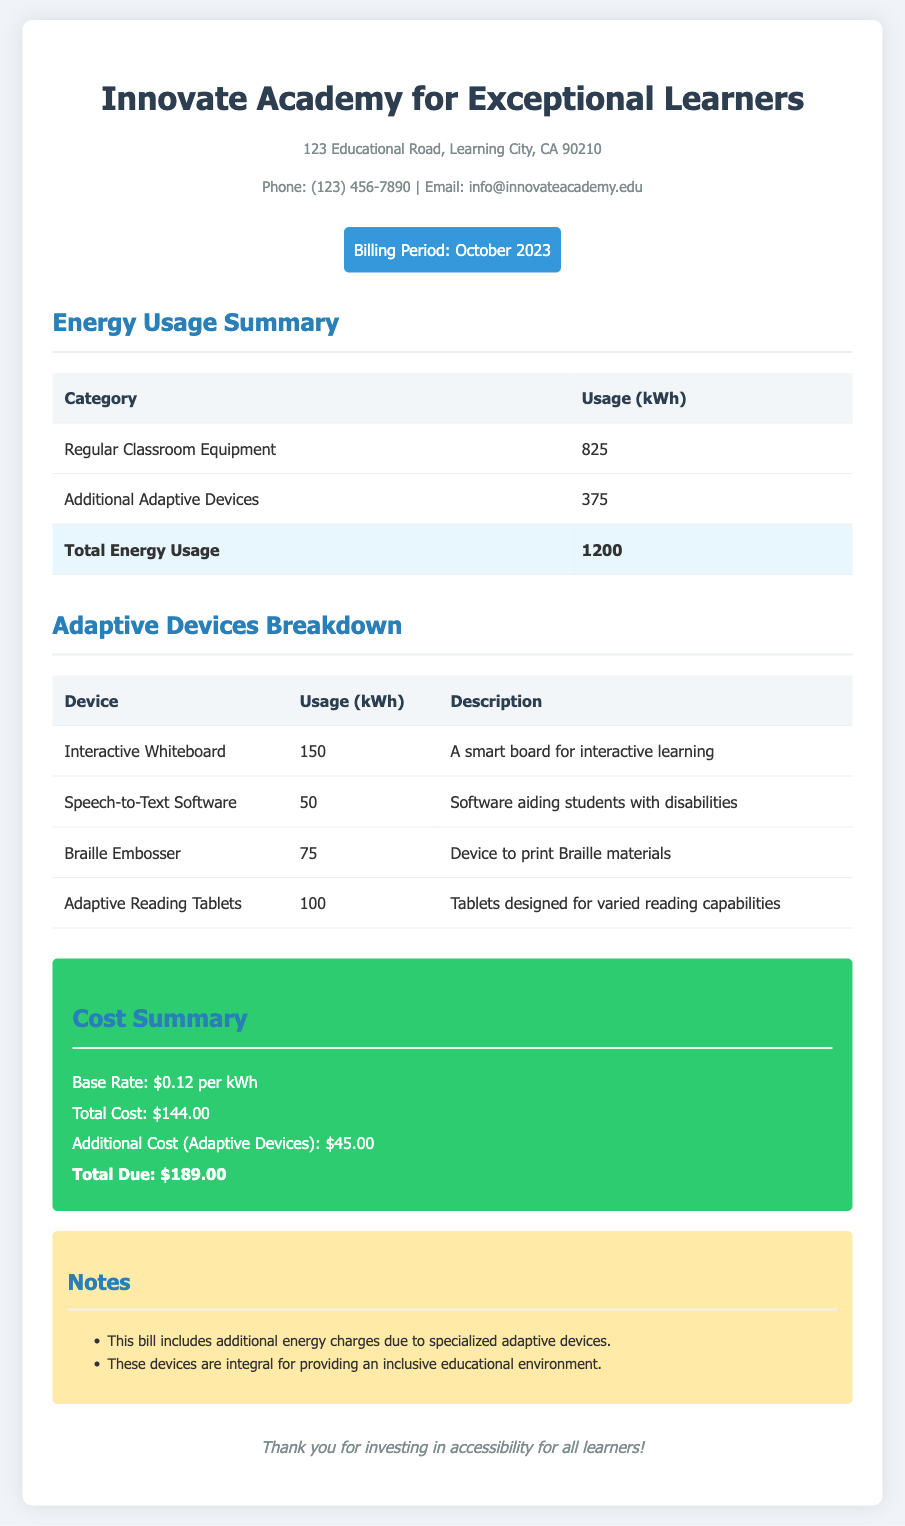What is the total energy usage? The total energy usage is the sum of regular classroom equipment and additional adaptive devices usage, which is 825 kWh + 375 kWh = 1200 kWh.
Answer: 1200 kWh What is the additional cost for adaptive devices? The additional cost for adaptive devices is specified in the cost summary section of the document.
Answer: $45.00 How much energy does the Interactive Whiteboard use? The usage for the Interactive Whiteboard is detailed in the Adaptive Devices Breakdown section.
Answer: 150 kWh What is the billing period for this utility bill? The billing period is indicated in the header of the document.
Answer: October 2023 What is the total due amount? The total due amount is provided in the cost summary section as the final calculation.
Answer: $189.00 How many kWh does the Speech-to-Text Software consume? The consumption for the Speech-to-Text Software is listed in the Adaptive Devices Breakdown table.
Answer: 50 kWh What is the base rate per kWh? The base rate is mentioned in the cost summary section of the document.
Answer: $0.12 per kWh Why are there additional energy charges? The notes section explains that additional energy charges are due to specialized adaptive devices.
Answer: Specialized adaptive devices What are the key functions of the Braille Embosser? The description column in the Adaptive Devices Breakdown table outlines the function of the Braille Embosser.
Answer: Device to print Braille materials 